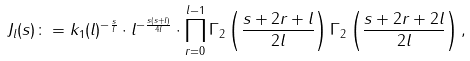Convert formula to latex. <formula><loc_0><loc_0><loc_500><loc_500>J _ { l } ( s ) \colon = k _ { 1 } ( l ) ^ { - \frac { s } { l } } \cdot l ^ { - \frac { s ( s + l ) } { 4 l } } \cdot \prod _ { r = 0 } ^ { l - 1 } \Gamma _ { 2 } \left ( \frac { s + 2 r + l } { 2 l } \right ) \Gamma _ { 2 } \left ( \frac { s + 2 r + 2 l } { 2 l } \right ) ,</formula> 